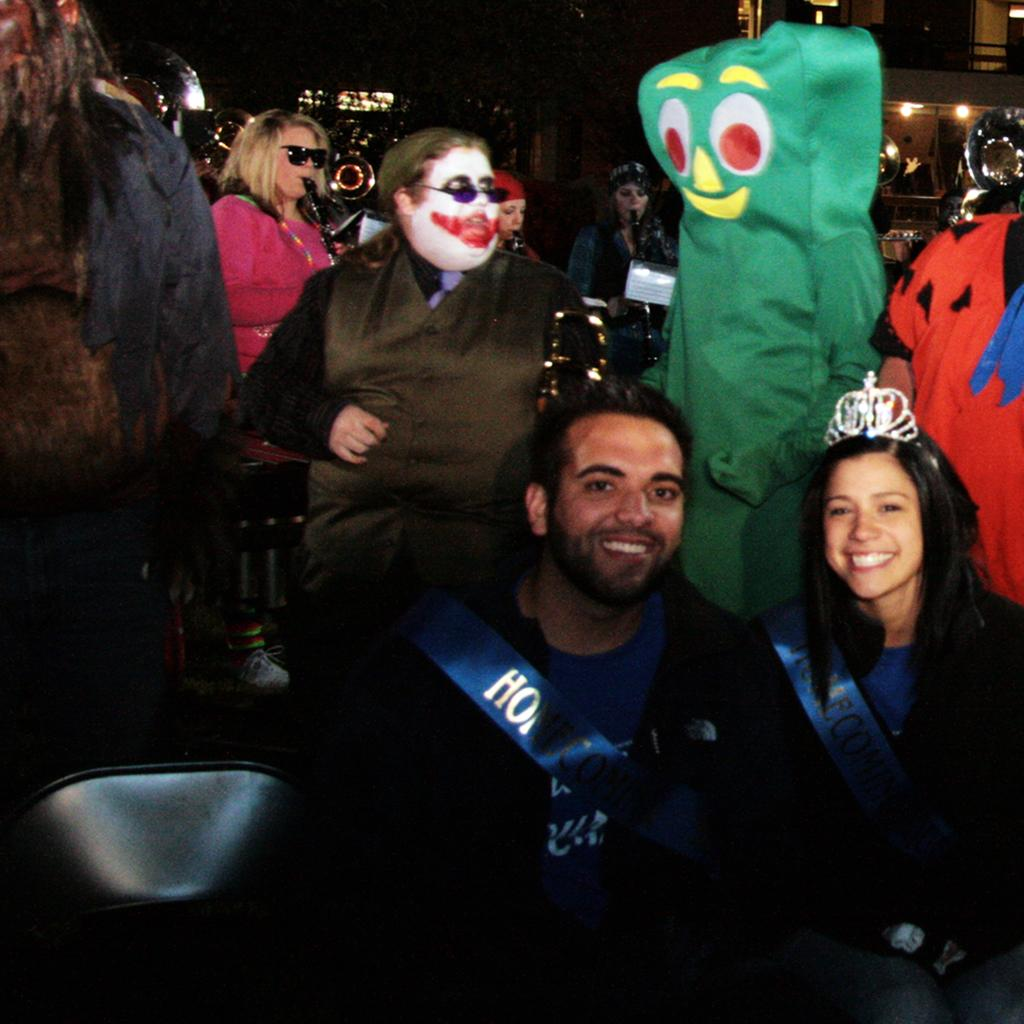Who are the main subjects in the image? There is a boy and a girl in the image. Where are the boy and girl located in the image? The boy and girl are on the right side of the image. Can you describe the background of the image? There are other people in the background of the image. What type of dinosaurs can be seen in the image? There are no dinosaurs present in the image; it features a boy and a girl on the right side of the image with other people in the background. 